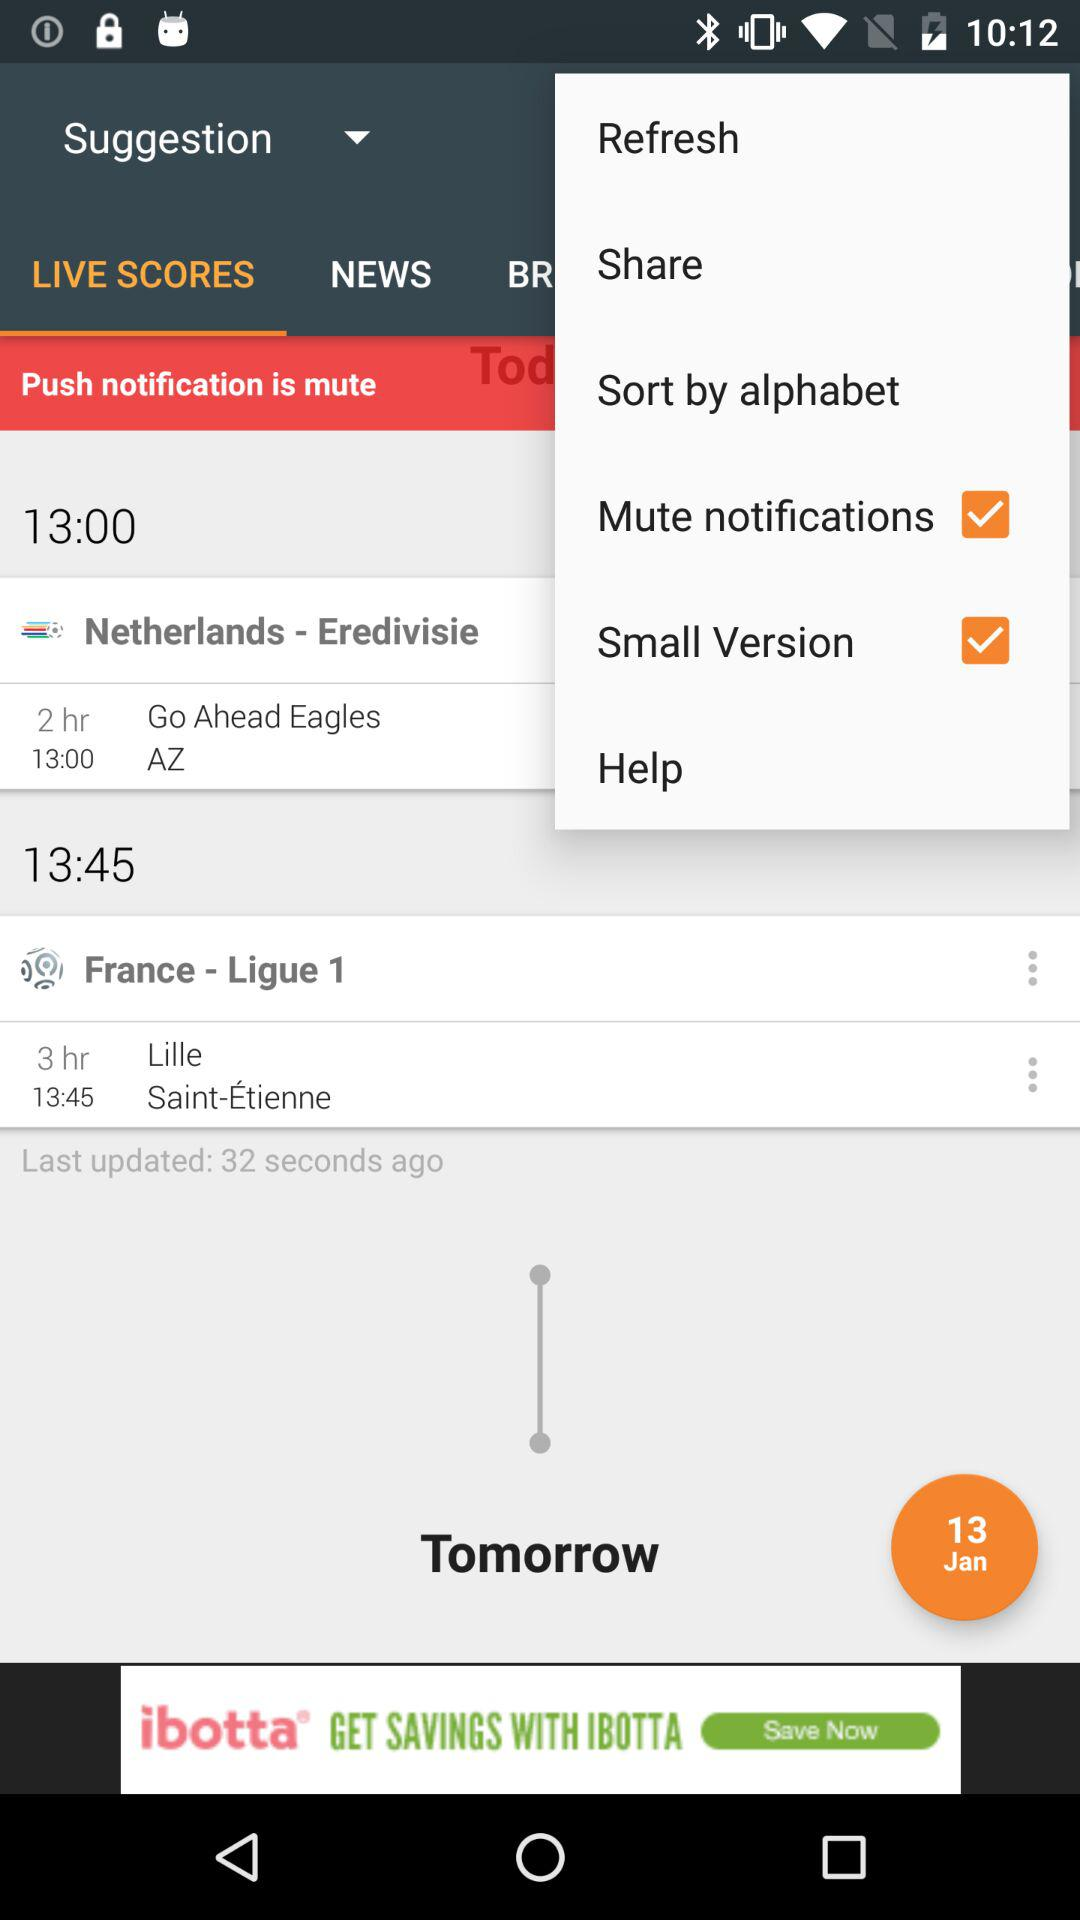What is the status of "Small Version"? The status is "on". 